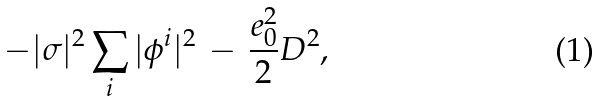Convert formula to latex. <formula><loc_0><loc_0><loc_500><loc_500>- | \sigma | ^ { 2 } \sum _ { i } | \phi ^ { i } | ^ { 2 } \, - \, \frac { e _ { 0 } ^ { 2 } } { 2 } D ^ { 2 } ,</formula> 